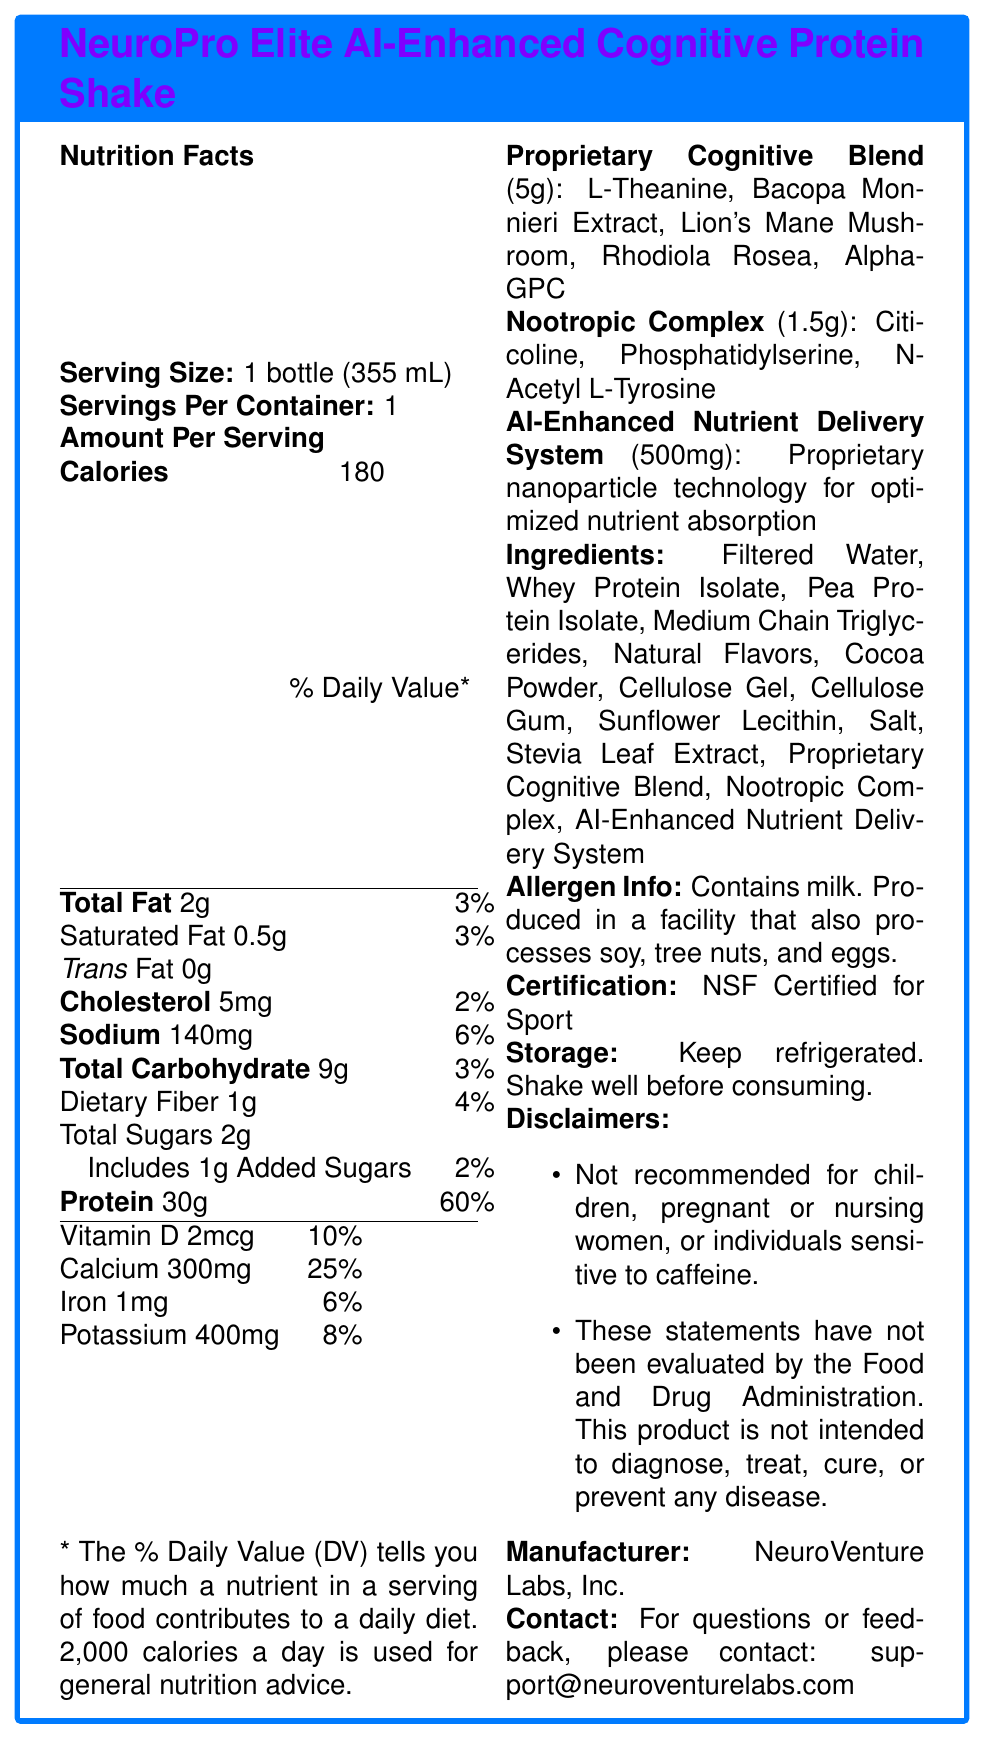What is the serving size of the NeuroPro Elite AI-Enhanced Cognitive Protein Shake? The serving size is specified as 1 bottle, which corresponds to 355 mL.
Answer: 1 bottle (355 mL) How many calories are in one serving of this protein shake? The document states that one serving contains 180 calories.
Answer: 180 What is the amount of protein per serving, and what is its daily value percentage? The document lists 30 grams of protein per serving, which amounts to 60% of the daily value.
Answer: 30g, 60% Which ingredient is used for optimized nutrient absorption in the NeuroPro Elite AI-Enhanced Cognitive Protein Shake? The ingredient listed for optimized nutrient absorption is the AI-Enhanced Nutrient Delivery System.
Answer: AI-Enhanced Nutrient Delivery System What allergens are present in the NeuroPro Elite AI-Enhanced Cognitive Protein Shake? The allergen information states that the product contains milk and is produced in a facility that also processes soy, tree nuts, and eggs.
Answer: Contains milk. Produced in a facility that also processes soy, tree nuts, and eggs. Which of these ingredients are part of the Proprietary Cognitive Blend? A. L-Theanine B. Citicoline C. Lion's Mane Mushroom D. Rhodiola Rosea E. Phosphatidylserine The Proprietary Cognitive Blend contains L-Theanine, Lion's Mane Mushroom, and Rhodiola Rosea.
Answer: A, C, D What percentage of the daily value does the total fat consist of? The total fat content per serving is 2g, which constitutes 3% of the daily value.
Answer: 3% How much calcium is in one serving, and what percentage of the daily value does it represent? One serving contains 300mg of calcium, which is 25% of the daily value.
Answer: 300mg, 25% Is this product recommended for children or pregnant women? The disclaimer specifically states that the product is not recommended for children or pregnant or nursing women.
Answer: No Summarize the main features of the NeuroPro Elite AI-Enhanced Cognitive Protein Shake. The document provides a comprehensive overview of the shake's nutritional content, its specialized ingredients for cognitive enhancement, its certification, and specific usage warnings.
Answer: The NeuroPro Elite AI-Enhanced Cognitive Protein Shake is a premium protein shake designed for peak cognitive performance. It contains a high amount of protein (30g per serving), various cognitive-enhancing ingredients, and uses proprietary nanoparticle technology for optimized nutrient absorption. The shake is NSF Certified for Sport and carries additional dietary and allergen information. It also contains disclaimers regarding its use for certain populations. What is the main ingredient in the AI-Enhanced Nutrient Delivery System? The document only describes the AI-Enhanced Nutrient Delivery System as "Proprietary nanoparticle technology for optimized nutrient absorption" and does not provide specific ingredients.
Answer: Cannot be determined What are the specific ingredients included in the Nootropic Complex? The document lists these three ingredients as components of the Nootropic Complex.
Answer: Citicoline, Phosphatidylserine, N-Acetyl L-Tyrosine Does the Proprietary Cognitive Blend contain more ingredients than the Nootropic Complex? The Proprietary Cognitive Blend contains 5 ingredients while the Nootropic Complex contains 3 ingredients.
Answer: Yes What is the contact email for questions or feedback regarding the product? The document provides this email address for any inquiries or feedback.
Answer: support@neuroventurelabs.com Who is the manufacturer of the NeuroPro Elite AI-Enhanced Cognitive Protein Shake? The manufacturer information at the end of the document states that the product is made by NeuroVenture Labs, Inc.
Answer: NeuroVenture Labs, Inc. 